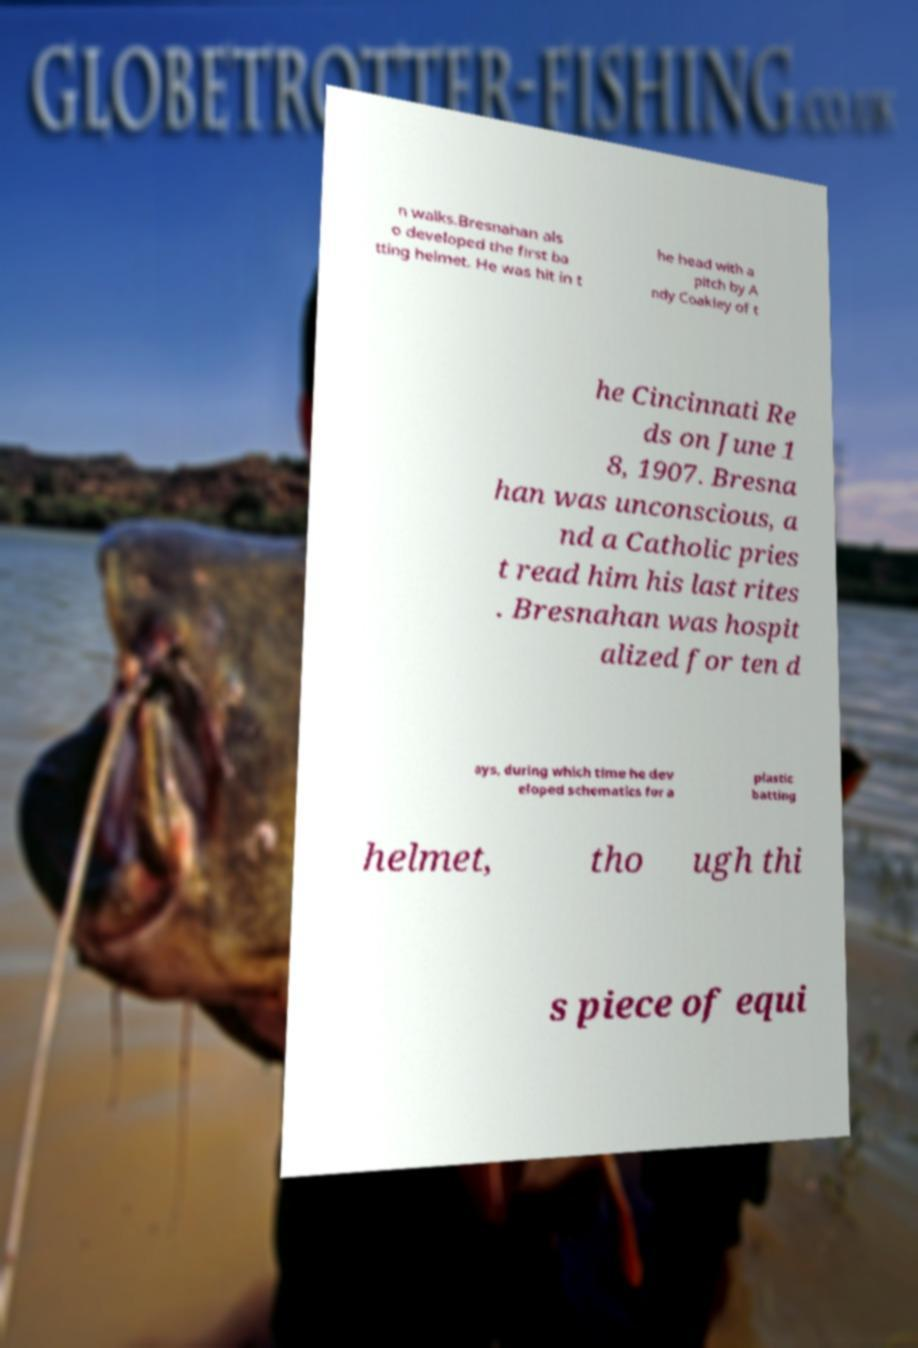I need the written content from this picture converted into text. Can you do that? n walks.Bresnahan als o developed the first ba tting helmet. He was hit in t he head with a pitch by A ndy Coakley of t he Cincinnati Re ds on June 1 8, 1907. Bresna han was unconscious, a nd a Catholic pries t read him his last rites . Bresnahan was hospit alized for ten d ays, during which time he dev eloped schematics for a plastic batting helmet, tho ugh thi s piece of equi 